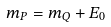Convert formula to latex. <formula><loc_0><loc_0><loc_500><loc_500>m _ { P } = m _ { Q } + E _ { 0 }</formula> 